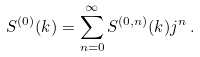Convert formula to latex. <formula><loc_0><loc_0><loc_500><loc_500>S ^ { ( 0 ) } ( k ) = \sum _ { n = 0 } ^ { \infty } S ^ { ( 0 , n ) } ( k ) j ^ { n } \, .</formula> 